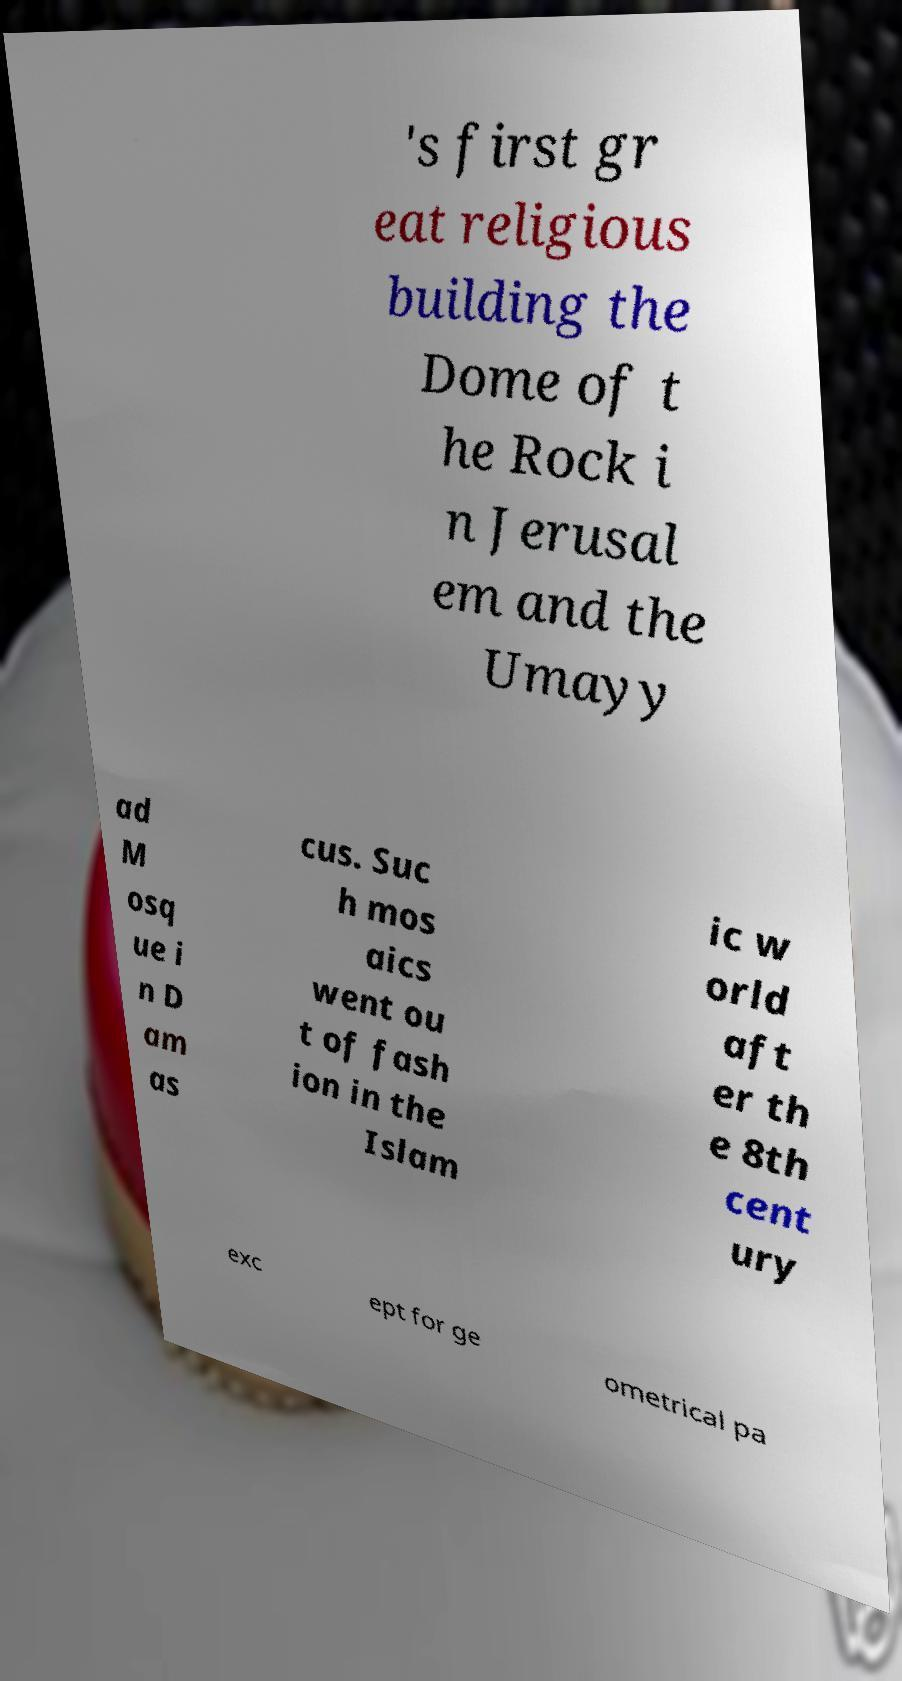There's text embedded in this image that I need extracted. Can you transcribe it verbatim? 's first gr eat religious building the Dome of t he Rock i n Jerusal em and the Umayy ad M osq ue i n D am as cus. Suc h mos aics went ou t of fash ion in the Islam ic w orld aft er th e 8th cent ury exc ept for ge ometrical pa 